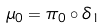<formula> <loc_0><loc_0><loc_500><loc_500>\mu _ { 0 } = \pi _ { 0 } \circ \delta _ { 1 }</formula> 